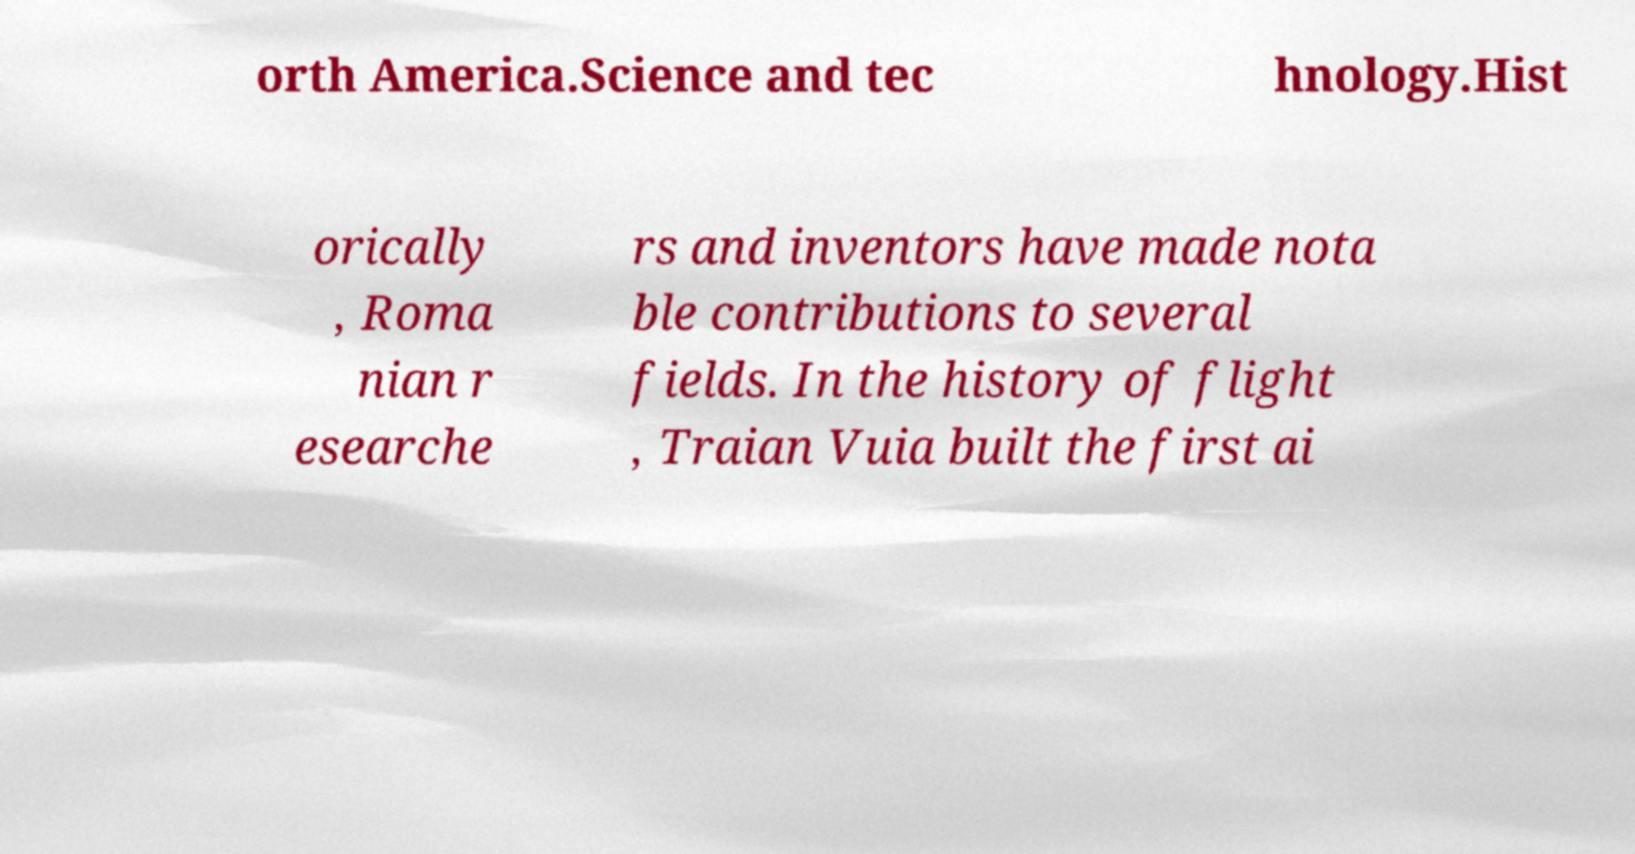Can you accurately transcribe the text from the provided image for me? orth America.Science and tec hnology.Hist orically , Roma nian r esearche rs and inventors have made nota ble contributions to several fields. In the history of flight , Traian Vuia built the first ai 